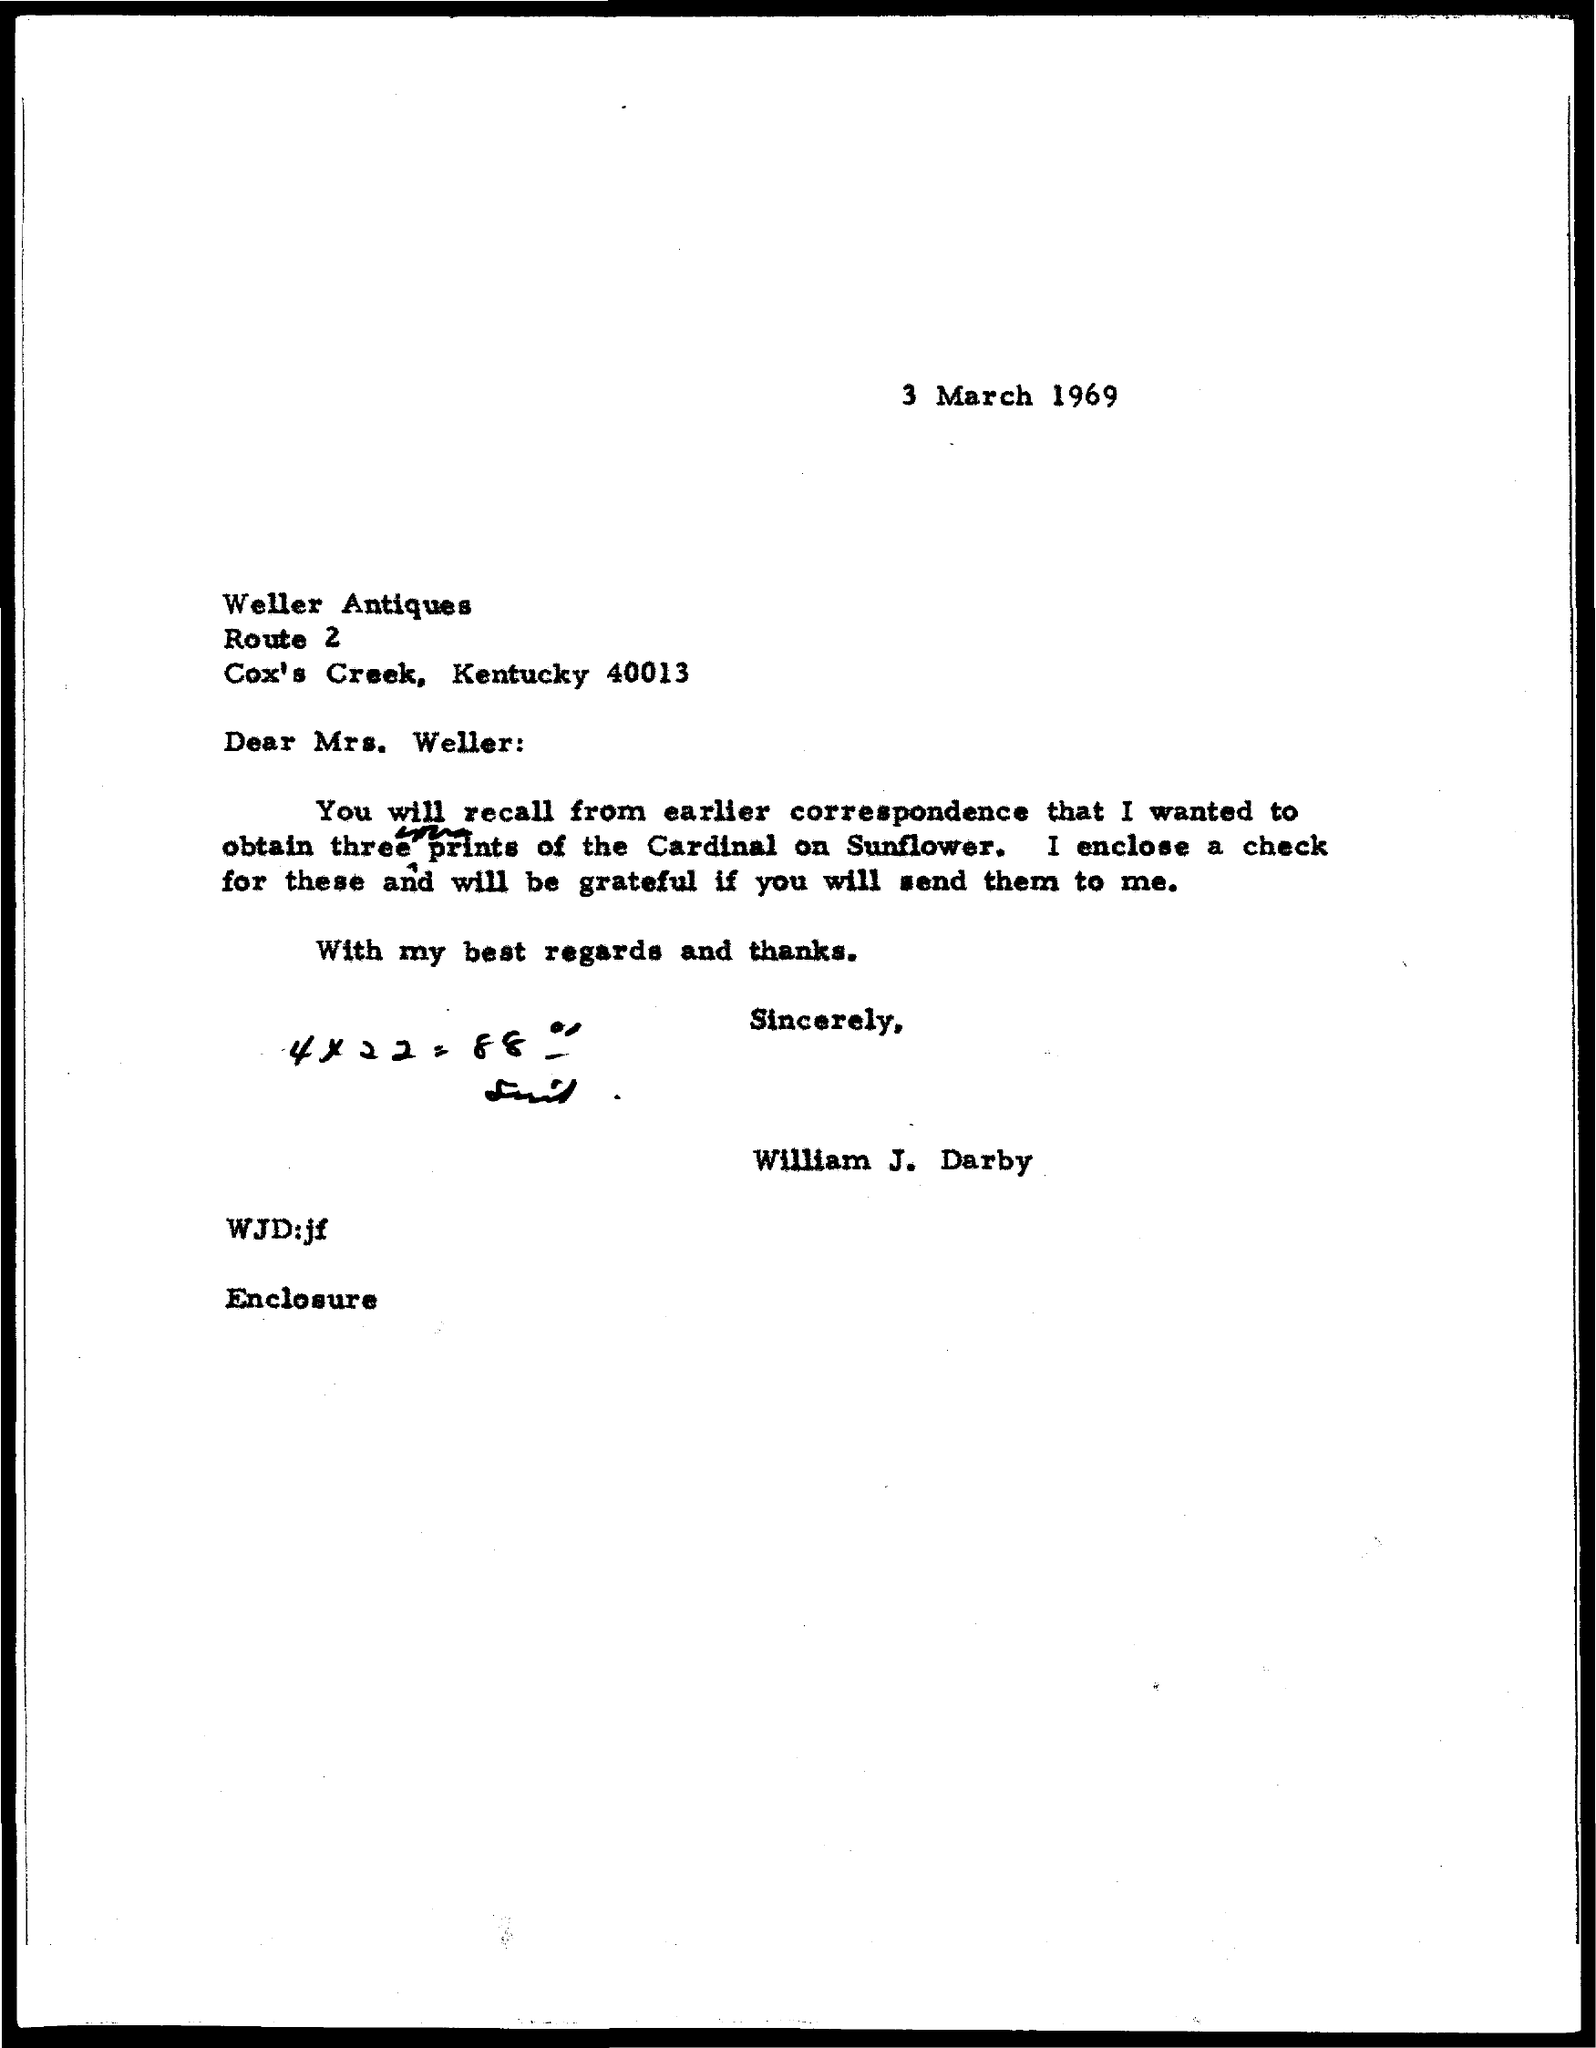When is the memorandum dated on ?
Provide a short and direct response. 3 March 1969. Who is the Memorandum Addressed to ?
Ensure brevity in your answer.  MRS. WELLER. 